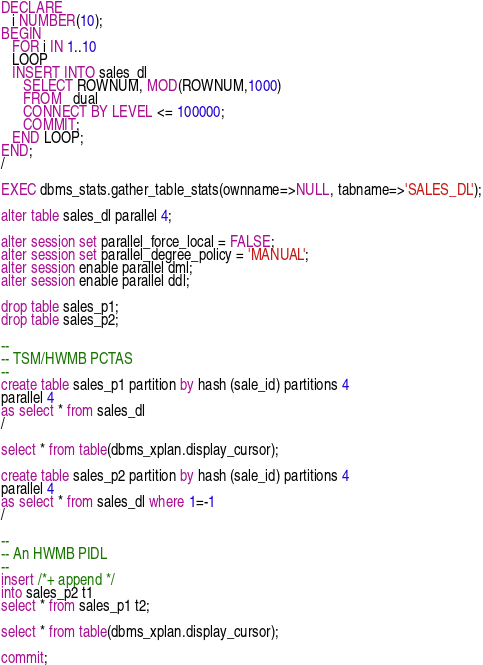<code> <loc_0><loc_0><loc_500><loc_500><_SQL_>DECLARE
   i NUMBER(10);
BEGIN
   FOR i IN 1..10
   LOOP
   INSERT INTO sales_dl
      SELECT ROWNUM, MOD(ROWNUM,1000)
      FROM   dual
      CONNECT BY LEVEL <= 100000;
      COMMIT;
   END LOOP;
END;
/

EXEC dbms_stats.gather_table_stats(ownname=>NULL, tabname=>'SALES_DL');

alter table sales_dl parallel 4;

alter session set parallel_force_local = FALSE;
alter session set parallel_degree_policy = 'MANUAL';
alter session enable parallel dml;
alter session enable parallel ddl;

drop table sales_p1;
drop table sales_p2;

--
-- TSM/HWMB PCTAS
--
create table sales_p1 partition by hash (sale_id) partitions 4 
parallel 4
as select * from sales_dl
/

select * from table(dbms_xplan.display_cursor);

create table sales_p2 partition by hash (sale_id) partitions 4 
parallel 4
as select * from sales_dl where 1=-1
/

--
-- An HWMB PIDL 
--
insert /*+ append */
into sales_p2 t1
select * from sales_p1 t2;

select * from table(dbms_xplan.display_cursor);

commit;

</code> 